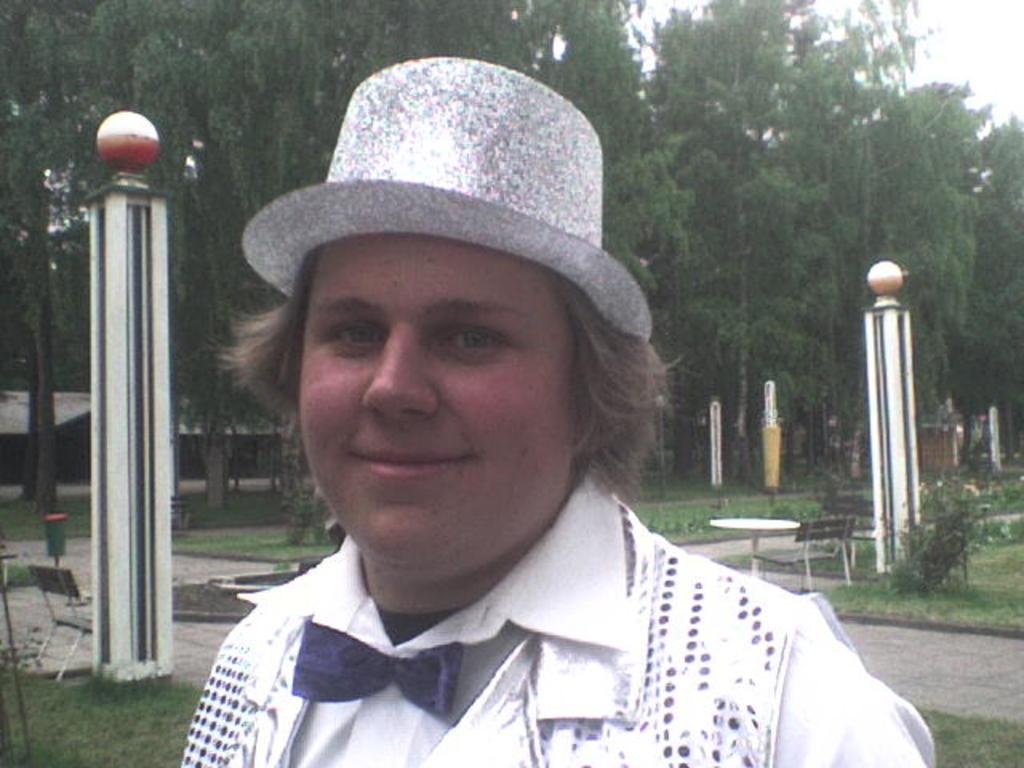Please provide a concise description of this image. It is a park and a person is standing in front of the camera and posing for the photo,behind the person there are some tables and benches beside the grass. 